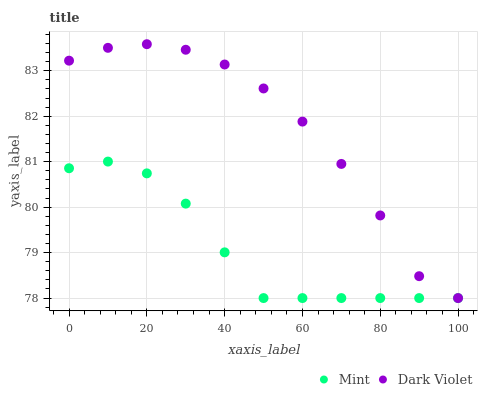Does Mint have the minimum area under the curve?
Answer yes or no. Yes. Does Dark Violet have the maximum area under the curve?
Answer yes or no. Yes. Does Dark Violet have the minimum area under the curve?
Answer yes or no. No. Is Mint the smoothest?
Answer yes or no. Yes. Is Dark Violet the roughest?
Answer yes or no. Yes. Is Dark Violet the smoothest?
Answer yes or no. No. Does Mint have the lowest value?
Answer yes or no. Yes. Does Dark Violet have the highest value?
Answer yes or no. Yes. Does Dark Violet intersect Mint?
Answer yes or no. Yes. Is Dark Violet less than Mint?
Answer yes or no. No. Is Dark Violet greater than Mint?
Answer yes or no. No. 